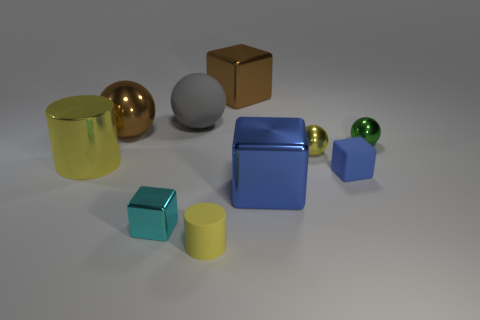The metal thing left of the big brown ball has what shape?
Offer a terse response. Cylinder. There is a brown object in front of the block behind the ball that is to the right of the tiny blue cube; what size is it?
Make the answer very short. Large. There is a cylinder that is behind the tiny blue matte block; how many big spheres are right of it?
Provide a succinct answer. 2. What size is the yellow thing that is both left of the blue metal thing and behind the small yellow cylinder?
Your answer should be very brief. Large. What number of metallic objects are either yellow things or spheres?
Your response must be concise. 4. What material is the large blue thing?
Offer a terse response. Metal. There is a yellow object to the left of the large brown thing to the left of the large block behind the big brown sphere; what is it made of?
Make the answer very short. Metal. The green thing that is the same size as the cyan cube is what shape?
Provide a succinct answer. Sphere. What number of objects are either large blue rubber cylinders or things that are behind the rubber cylinder?
Your answer should be very brief. 9. Is the material of the tiny block in front of the large blue cube the same as the small cube to the right of the tiny yellow cylinder?
Make the answer very short. No. 